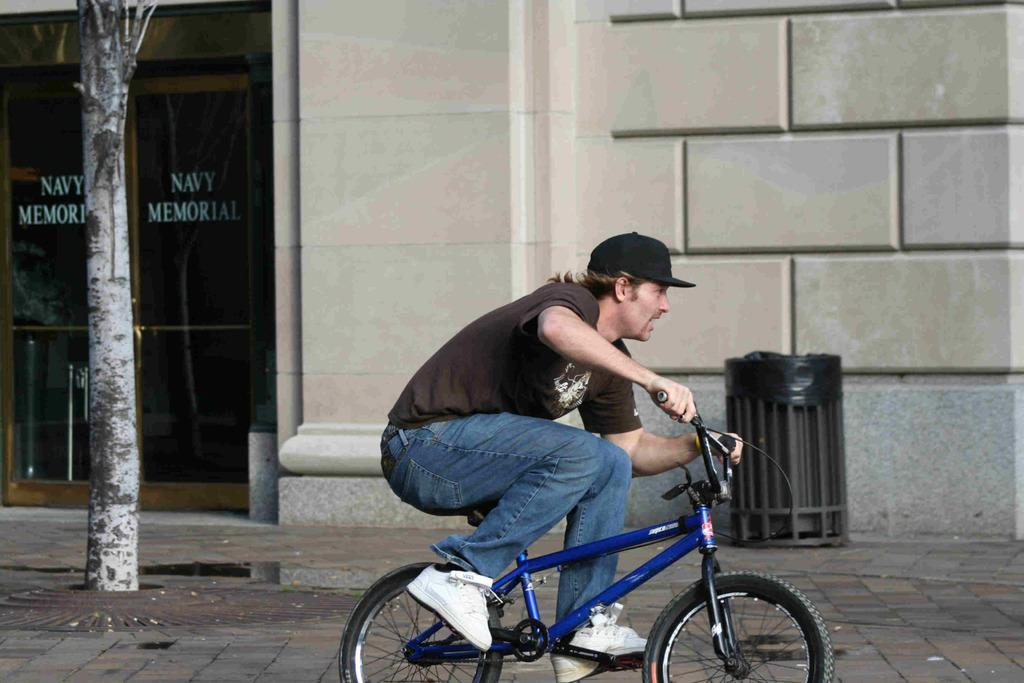What type of path is visible in the image? There is a footpath in the image. What is the man on the footpath doing? A man is riding a cycle on the footpath. Where is the dustbin located in relation to the footpath? The dustbin is on the left side of the footpath. What can be seen in the background of the image? There is a door and a marble wall in the background of the image. How does the man on the footpath feel about his recent loss? There is no information about the man's emotions or any loss in the image, so it cannot be determined from the image. 